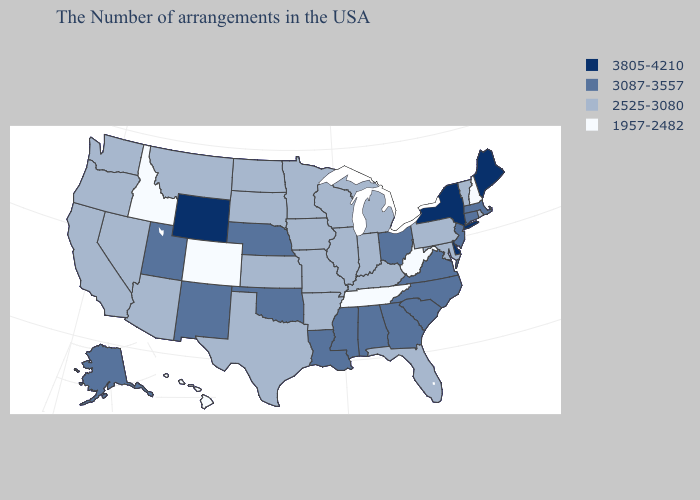Does Wyoming have a higher value than Ohio?
Give a very brief answer. Yes. Does the map have missing data?
Be succinct. No. Name the states that have a value in the range 2525-3080?
Answer briefly. Rhode Island, Vermont, Maryland, Pennsylvania, Florida, Michigan, Kentucky, Indiana, Wisconsin, Illinois, Missouri, Arkansas, Minnesota, Iowa, Kansas, Texas, South Dakota, North Dakota, Montana, Arizona, Nevada, California, Washington, Oregon. What is the value of Idaho?
Write a very short answer. 1957-2482. Among the states that border South Carolina , which have the highest value?
Give a very brief answer. North Carolina, Georgia. What is the value of Oregon?
Be succinct. 2525-3080. What is the value of Rhode Island?
Write a very short answer. 2525-3080. Does North Dakota have a higher value than West Virginia?
Quick response, please. Yes. What is the value of Vermont?
Quick response, please. 2525-3080. Name the states that have a value in the range 1957-2482?
Short answer required. New Hampshire, West Virginia, Tennessee, Colorado, Idaho, Hawaii. What is the highest value in the South ?
Keep it brief. 3805-4210. Name the states that have a value in the range 1957-2482?
Concise answer only. New Hampshire, West Virginia, Tennessee, Colorado, Idaho, Hawaii. Does Hawaii have the lowest value in the USA?
Keep it brief. Yes. What is the lowest value in states that border Rhode Island?
Short answer required. 3087-3557. 